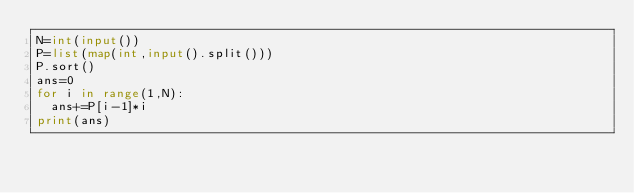Convert code to text. <code><loc_0><loc_0><loc_500><loc_500><_Python_>N=int(input())
P=list(map(int,input().split()))
P.sort()
ans=0
for i in range(1,N):
  ans+=P[i-1]*i
print(ans)  </code> 